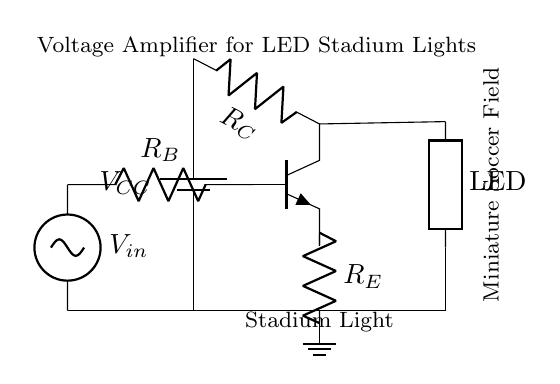What is the type of transistor used in this circuit? The circuit uses an NPN transistor, which can be identified by its symbol on the diagram.
Answer: NPN What is the input voltage in the circuit? The input voltage is represented by \( V_{in} \), which is indicated in the diagram.
Answer: \( V_{in} \) What component is directly connected to the collector of the transistor? The component connected to the collector is the LED, which is shown in the circuit diagram.
Answer: LED How many resistors are present in the circuit? There are three resistors in total: \( R_B \), \( R_C \), and \( R_E \) as seen in the diagram.
Answer: 3 What is the role of the emitter resistor in this amplifier circuit? The emitter resistor \( R_E \) stabilizes the transistor's operation by providing feedback and controlling the gain, aiding in linearity.
Answer: Stabilization What is the output component of this amplifier circuit? The output component is the LED, which illuminates as a result of the amplified voltage.
Answer: LED What is the purpose of the collector resistor in this circuit? The collector resistor \( R_C \) helps to limit the current through the transistor and the LED, ensuring that they operate within safe limits.
Answer: Current Limitation 